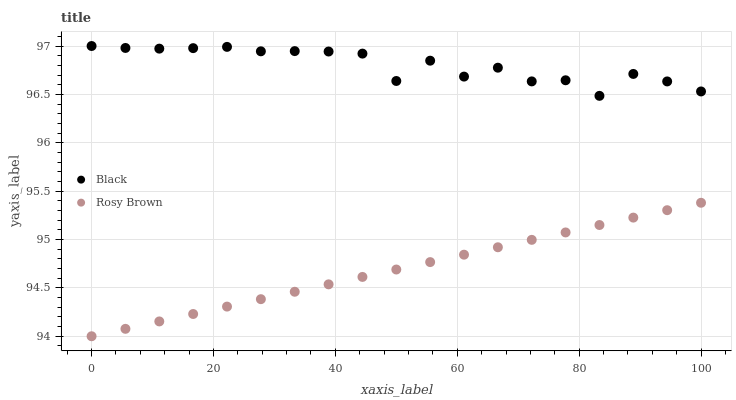Does Rosy Brown have the minimum area under the curve?
Answer yes or no. Yes. Does Black have the maximum area under the curve?
Answer yes or no. Yes. Does Black have the minimum area under the curve?
Answer yes or no. No. Is Rosy Brown the smoothest?
Answer yes or no. Yes. Is Black the roughest?
Answer yes or no. Yes. Is Black the smoothest?
Answer yes or no. No. Does Rosy Brown have the lowest value?
Answer yes or no. Yes. Does Black have the lowest value?
Answer yes or no. No. Does Black have the highest value?
Answer yes or no. Yes. Is Rosy Brown less than Black?
Answer yes or no. Yes. Is Black greater than Rosy Brown?
Answer yes or no. Yes. Does Rosy Brown intersect Black?
Answer yes or no. No. 